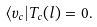Convert formula to latex. <formula><loc_0><loc_0><loc_500><loc_500>\langle v _ { c } | T _ { c } ( l ) = 0 .</formula> 